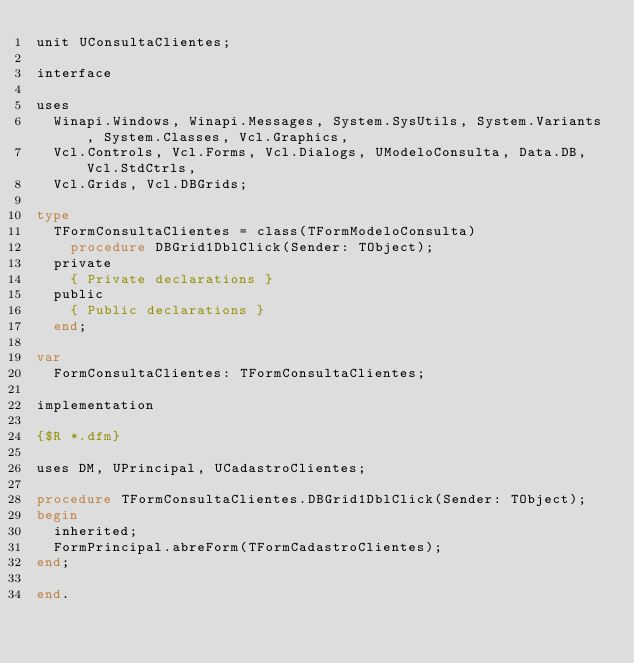Convert code to text. <code><loc_0><loc_0><loc_500><loc_500><_Pascal_>unit UConsultaClientes;

interface

uses
  Winapi.Windows, Winapi.Messages, System.SysUtils, System.Variants, System.Classes, Vcl.Graphics,
  Vcl.Controls, Vcl.Forms, Vcl.Dialogs, UModeloConsulta, Data.DB, Vcl.StdCtrls,
  Vcl.Grids, Vcl.DBGrids;

type
  TFormConsultaClientes = class(TFormModeloConsulta)
    procedure DBGrid1DblClick(Sender: TObject);
  private
    { Private declarations }
  public
    { Public declarations }
  end;

var
  FormConsultaClientes: TFormConsultaClientes;

implementation

{$R *.dfm}

uses DM, UPrincipal, UCadastroClientes;

procedure TFormConsultaClientes.DBGrid1DblClick(Sender: TObject);
begin
  inherited;
  FormPrincipal.abreForm(TFormCadastroClientes);
end;

end.
</code> 